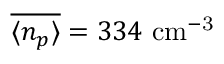Convert formula to latex. <formula><loc_0><loc_0><loc_500><loc_500>\overline { { \langle n _ { p } \rangle } } = 3 3 4 c m ^ { - 3 }</formula> 